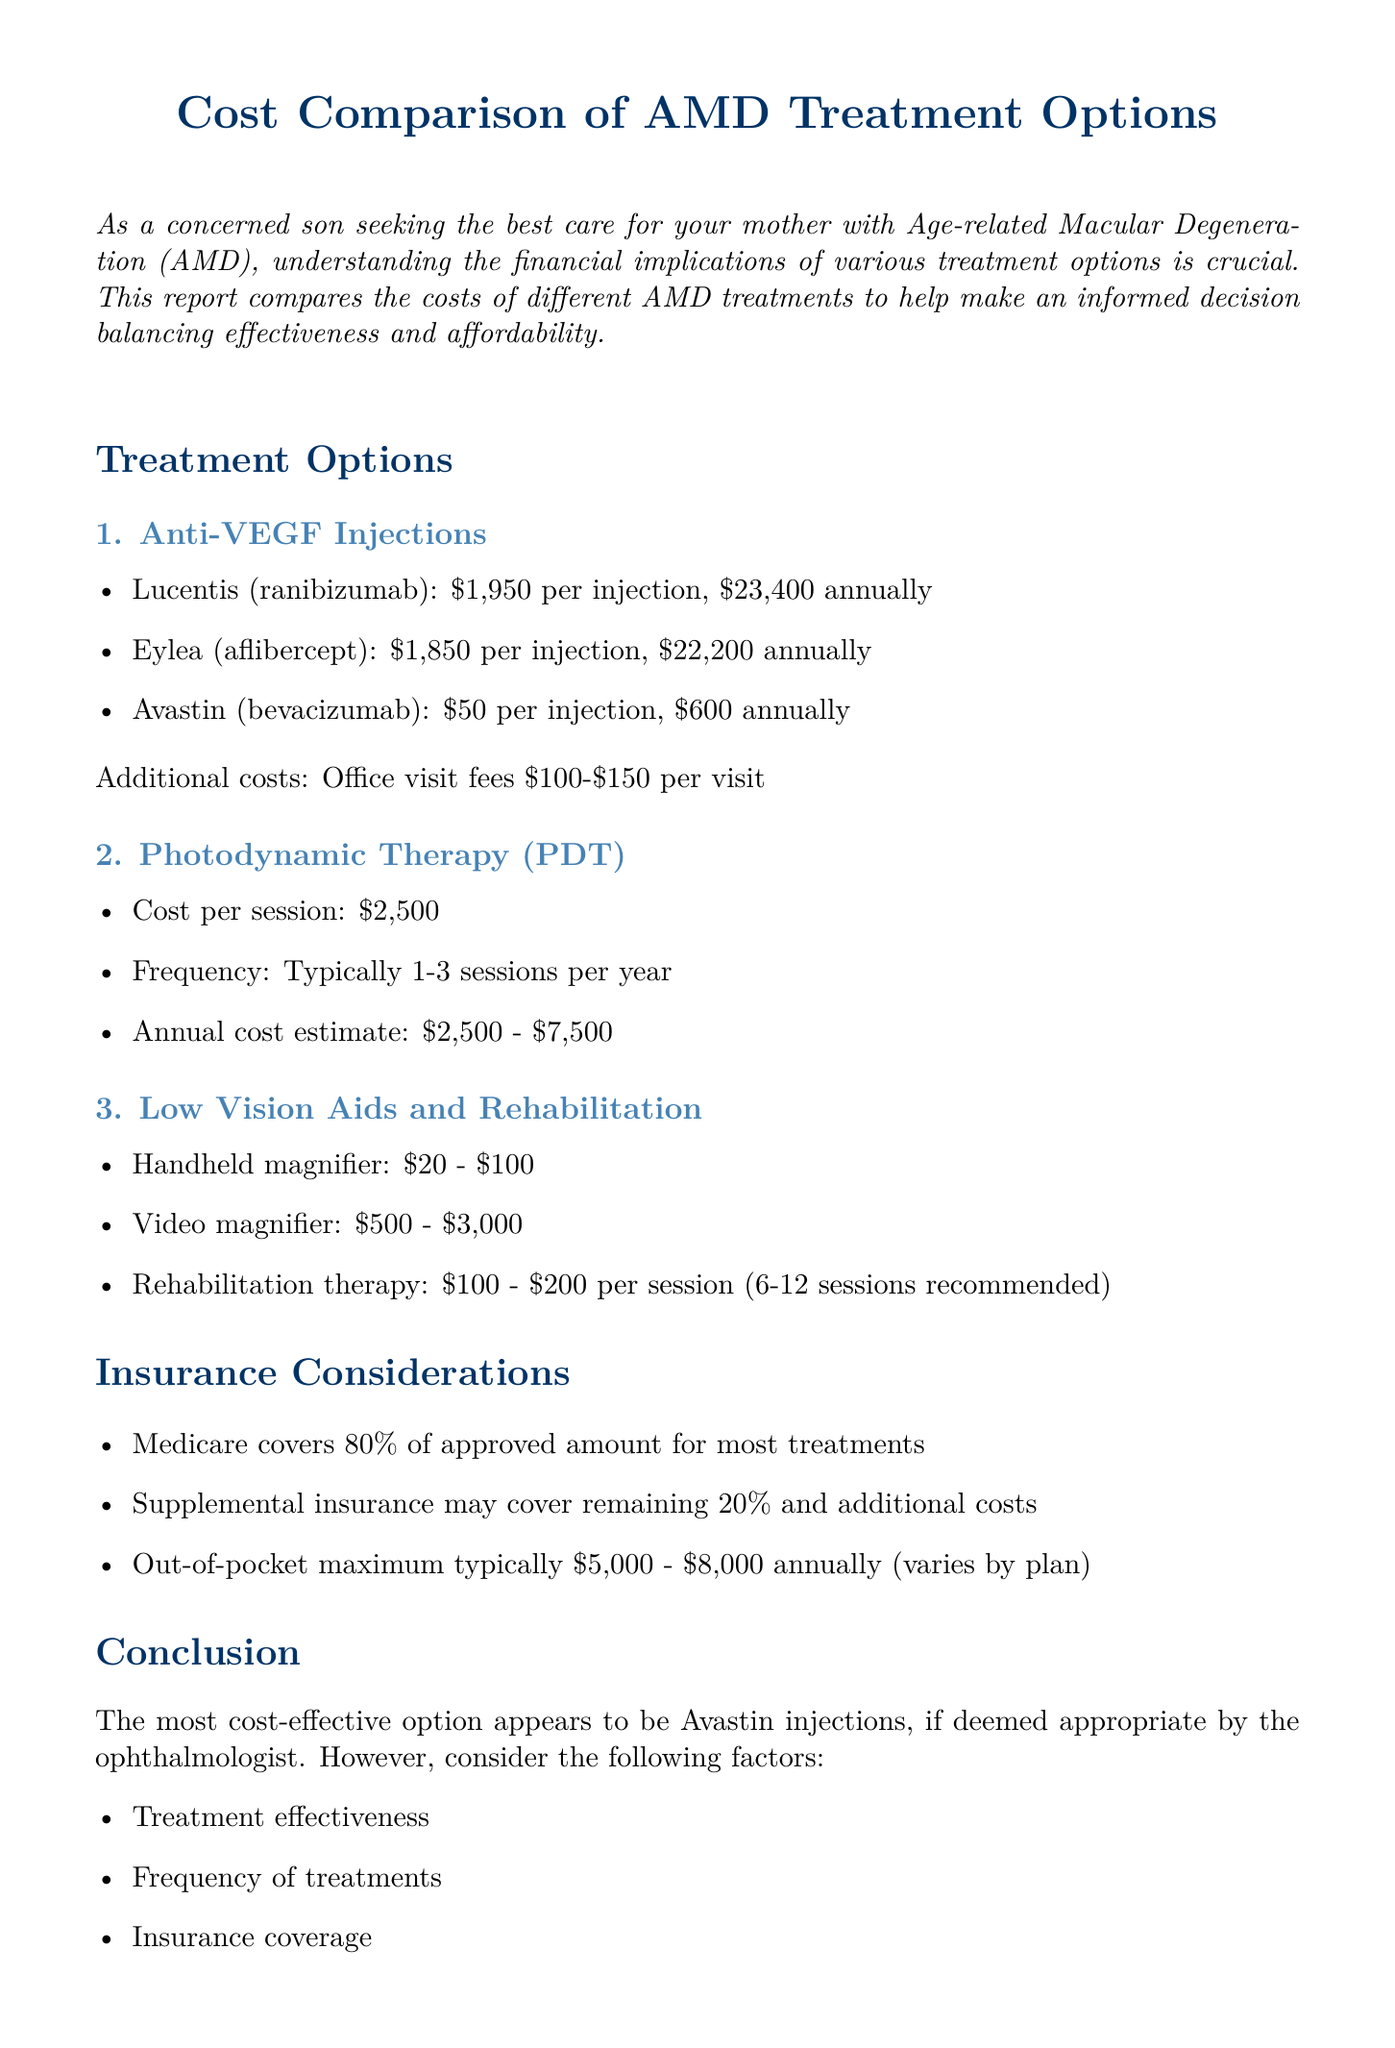What is the cost per injection of Lucentis? The cost per injection of Lucentis (ranibizumab) is specified in the document.
Answer: $1,950 What is the estimated annual cost for Eylea? The annual cost estimate for Eylea (aflibercept) is mentioned based on 12 injections per year.
Answer: $22,200 How many sessions are typically needed for Photodynamic Therapy? The frequency of sessions for Photodynamic Therapy is indicated in the document.
Answer: 1-3 sessions What is the lowest cost option for AMD injections? The document identifies the most cost-effective injection option for AMD treatment.
Answer: Avastin injections What percentage of treatment costs does Medicare cover? The coverage percentage provided by Medicare for AMD treatments is stated in the document.
Answer: 80% What is the estimated cost range for rehabilitation therapy sessions? The document details the cost per session for rehabilitation therapy and the recommended sessions.
Answer: $100 - $200 per session What additional costs are associated with Anti-VEGF injections? The document lists additional costs related to office visits for Anti-VEGF injections.
Answer: Office visit fees: $100-$150 per visit What should be considered apart from cost when choosing a treatment? The document outlines several factors that should be taken into account when deciding on a treatment option.
Answer: Treatment effectiveness, frequency of treatments, insurance coverage, potential side effects, mother's overall health and preferences 